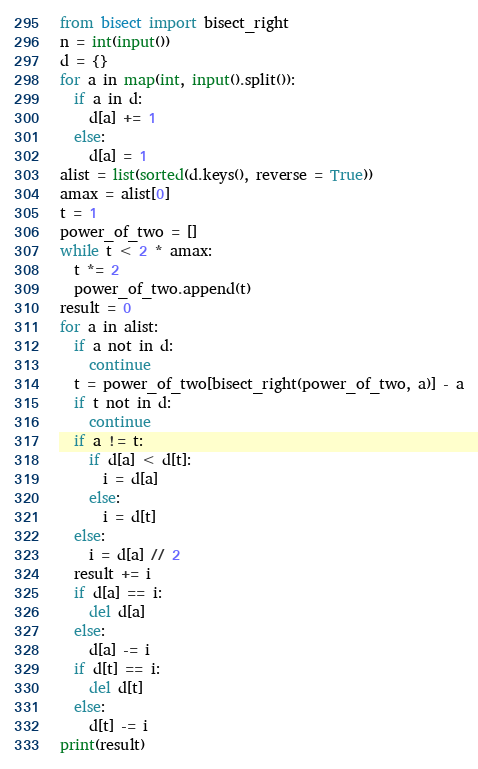Convert code to text. <code><loc_0><loc_0><loc_500><loc_500><_Python_>from bisect import bisect_right
n = int(input())
d = {}
for a in map(int, input().split()):
  if a in d:
    d[a] += 1
  else:
    d[a] = 1
alist = list(sorted(d.keys(), reverse = True))
amax = alist[0]
t = 1
power_of_two = []
while t < 2 * amax:
  t *= 2
  power_of_two.append(t)
result = 0
for a in alist:
  if a not in d:
    continue
  t = power_of_two[bisect_right(power_of_two, a)] - a
  if t not in d:
    continue
  if a != t:
    if d[a] < d[t]:
      i = d[a]
    else:
      i = d[t]
  else:
    i = d[a] // 2
  result += i  
  if d[a] == i:
    del d[a]
  else:
    d[a] -= i
  if d[t] == i:
    del d[t]
  else:
    d[t] -= i
print(result)
</code> 